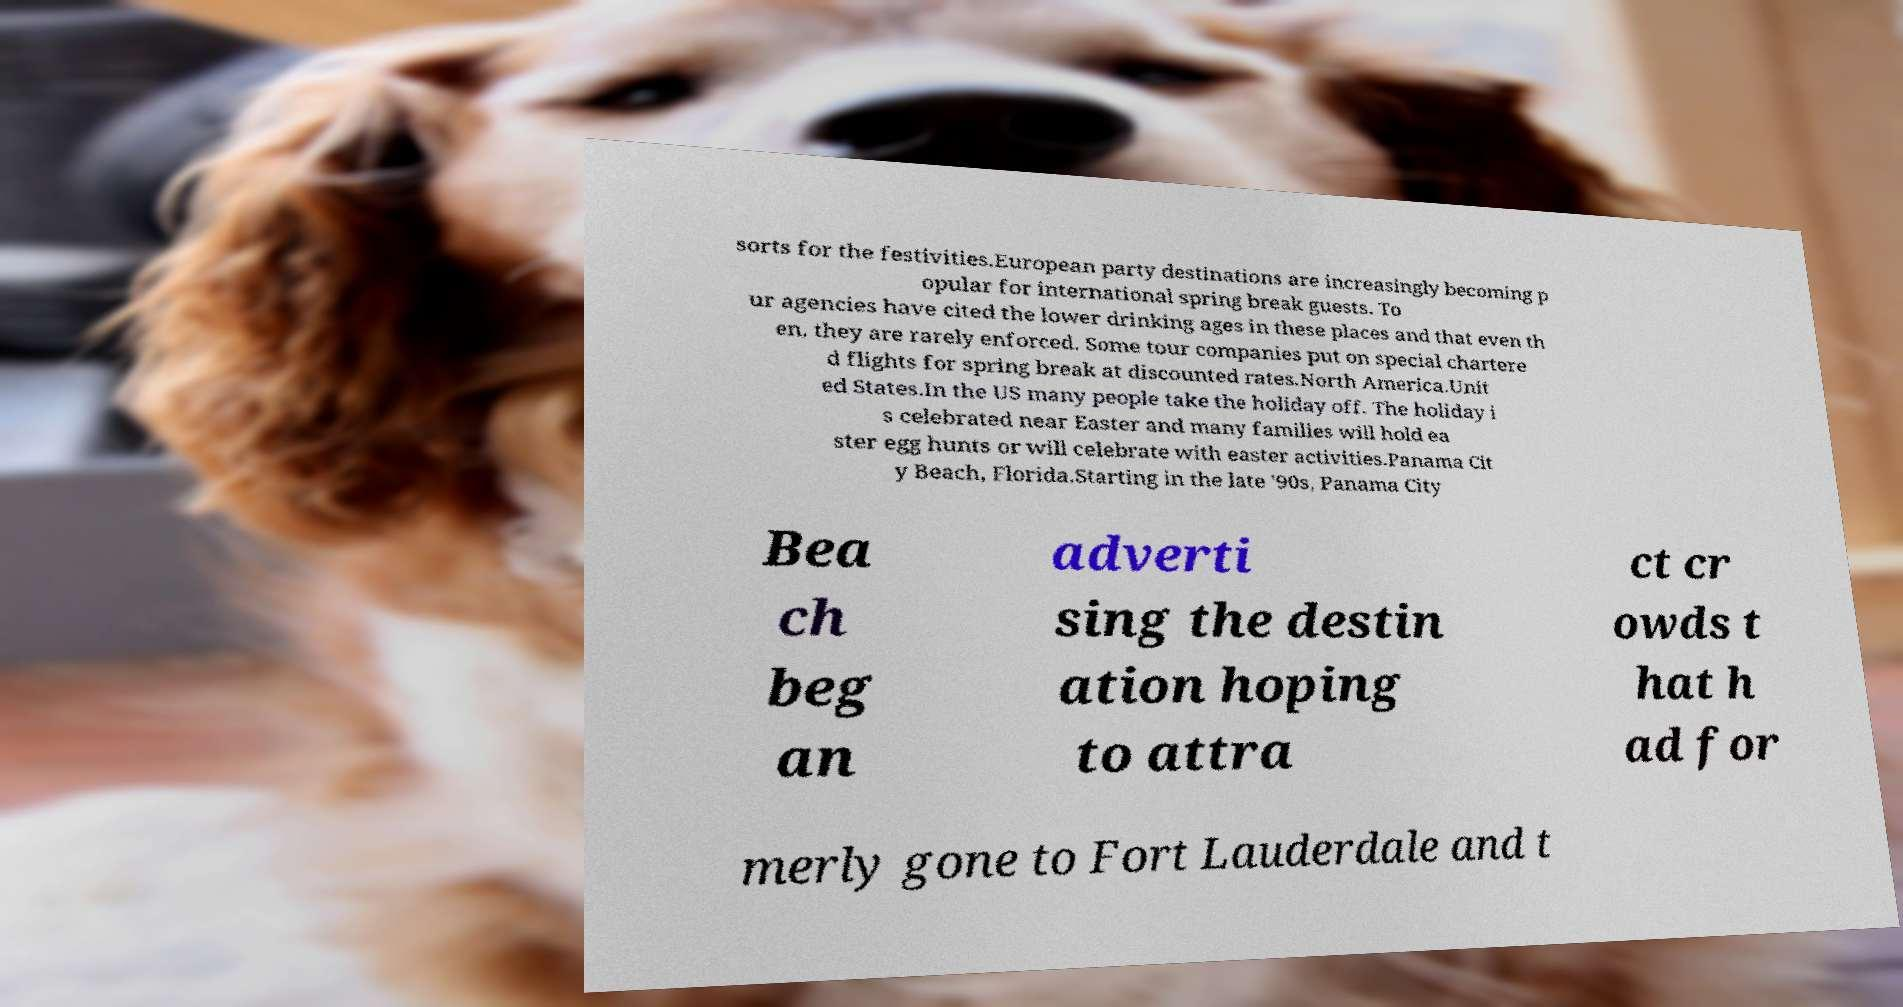Can you read and provide the text displayed in the image?This photo seems to have some interesting text. Can you extract and type it out for me? sorts for the festivities.European party destinations are increasingly becoming p opular for international spring break guests. To ur agencies have cited the lower drinking ages in these places and that even th en, they are rarely enforced. Some tour companies put on special chartere d flights for spring break at discounted rates.North America.Unit ed States.In the US many people take the holiday off. The holiday i s celebrated near Easter and many families will hold ea ster egg hunts or will celebrate with easter activities.Panama Cit y Beach, Florida.Starting in the late '90s, Panama City Bea ch beg an adverti sing the destin ation hoping to attra ct cr owds t hat h ad for merly gone to Fort Lauderdale and t 